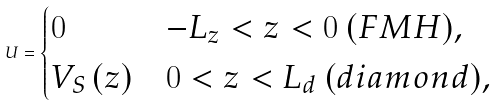Convert formula to latex. <formula><loc_0><loc_0><loc_500><loc_500>U = \begin{cases} 0 & - L _ { z } < z < 0 \ ( F M H ) , \\ V _ { S } \left ( z \right ) & 0 < z < L _ { d } \ ( d i a m o n d ) , \end{cases}</formula> 